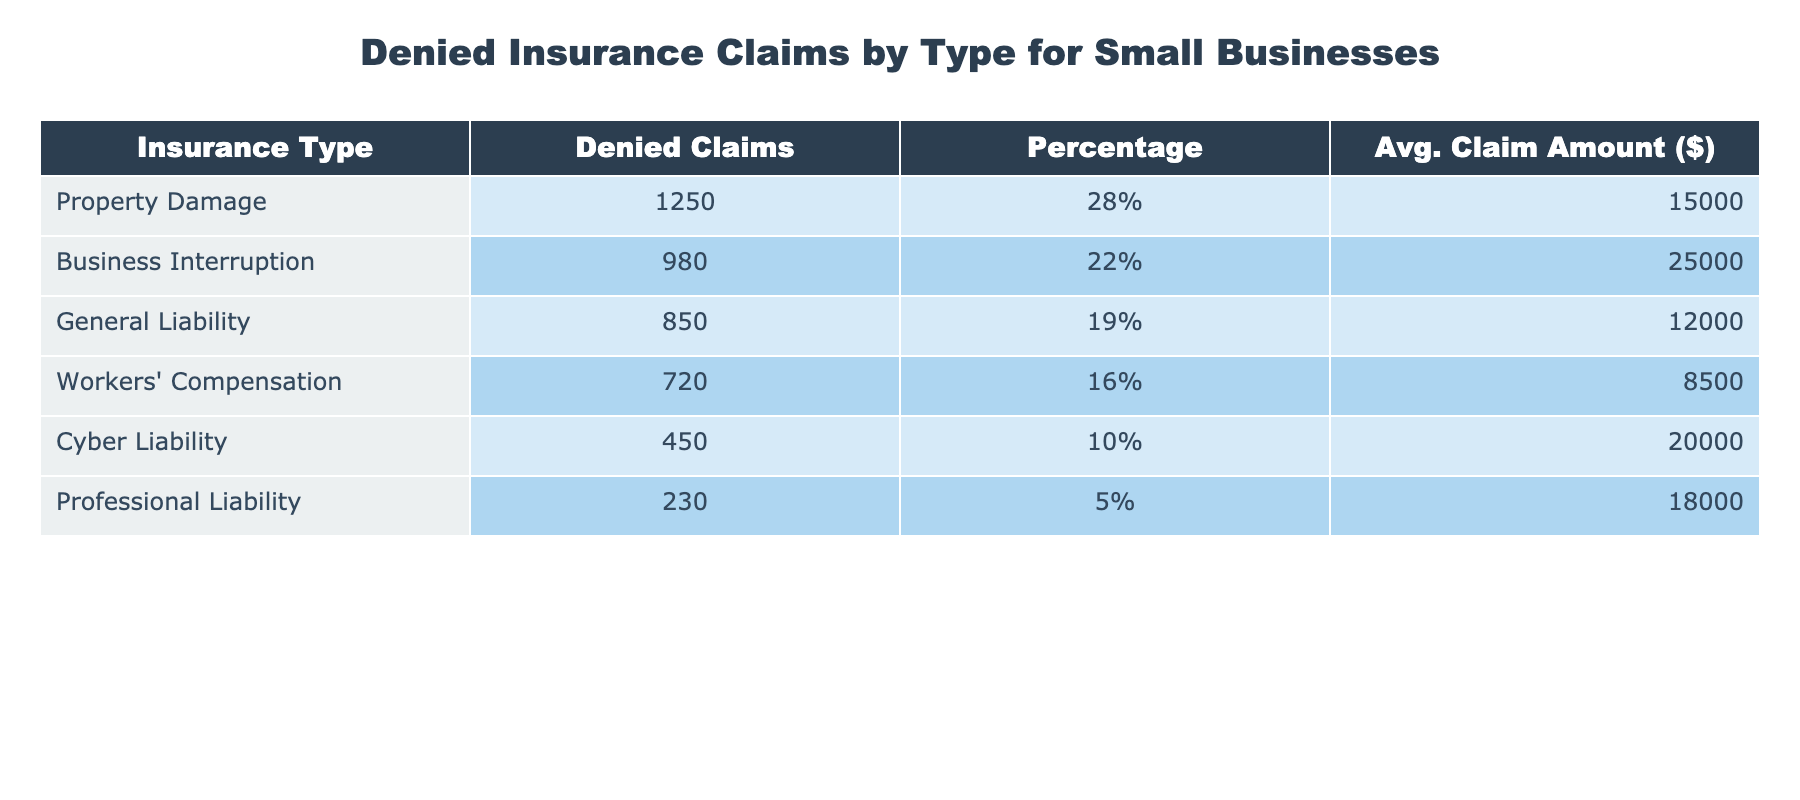What type of insurance had the highest number of denied claims? Looking at the table, the type of insurance with the highest number of denied claims is Property Damage, with 1250 denied claims.
Answer: Property Damage What percentage of total claims did Cyber Liability represent? The table shows that Cyber Liability accounted for 10% of total claims, as stated in the percentage column.
Answer: 10% What is the average claim amount for Business Interruption? The average claim amount for Business Interruption is listed as $25,000 in the table under the corresponding column.
Answer: $25,000 Which type of insurance had the lowest number of denied claims? From the table, the type of insurance with the lowest number of denied claims is Professional Liability, with 230 denied claims.
Answer: Professional Liability What is the total number of denied claims for Property Damage and General Liability combined? The number of denied claims for Property Damage is 1250 and for General Liability is 850. Adding them together gives 1250 + 850 = 2100 denied claims in total.
Answer: 2100 Is the average claim amount for Workers' Compensation higher than that of Professional Liability? The average claim amount for Workers' Compensation is $8,500, while for Professional Liability it is $18,000. Since $8,500 is not higher than $18,000, the answer is no.
Answer: No What is the difference in the number of denied claims between Business Interruption and Workers' Compensation? The number of denied claims for Business Interruption is 980 and for Workers' Compensation is 720. The difference is 980 - 720 = 260 denied claims.
Answer: 260 Which insurance type has a higher average claim amount, Cyber Liability or General Liability? The average claim amount for Cyber Liability is $20,000 and for General Liability is $12,000. Since $20,000 is more than $12,000, Cyber Liability has the higher average claim amount.
Answer: Cyber Liability What is the total percentage of denied claims for the four largest categories of insurance? The four largest categories are Property Damage (28%), Business Interruption (22%), General Liability (19%), and Workers' Compensation (16%). Adding these percentages yields 28 + 22 + 19 + 16 = 85%.
Answer: 85% Is it true that more denied claims were recorded for Workers' Compensation than for Cyber Liability? Workers' Compensation has 720 denied claims, while Cyber Liability has 450. Since 720 is greater than 450, the statement is true.
Answer: True 